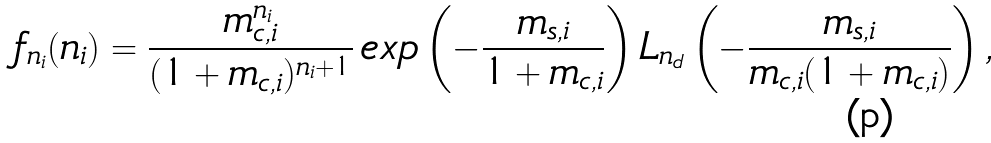Convert formula to latex. <formula><loc_0><loc_0><loc_500><loc_500>f _ { n _ { i } } ( n _ { i } ) = \frac { m _ { c , i } ^ { n _ { i } } } { ( 1 + m _ { c , i } ) ^ { n _ { i } + 1 } } \, e x p \left ( - \frac { m _ { s , i } } { 1 + m _ { c , i } } \right ) L _ { n _ { d } } \left ( - \frac { m _ { s , i } } { m _ { c , i } ( 1 + m _ { c , i } ) } \right ) ,</formula> 